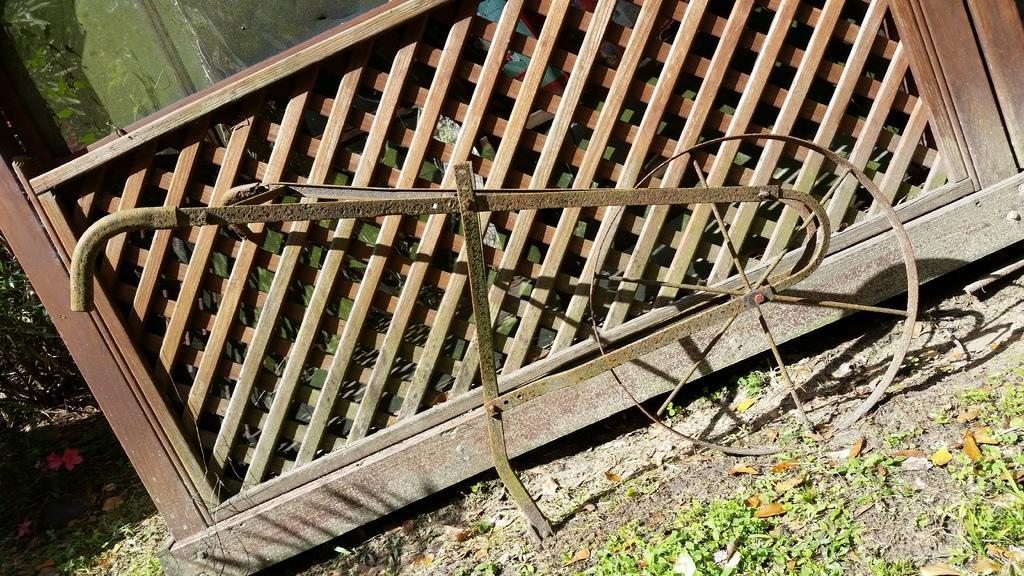Could you give a brief overview of what you see in this image? In this picture we can see an iron object and a wooden object on the path. Behind the wooden object there is a glass and plants. On the path there are some dry leaves. 